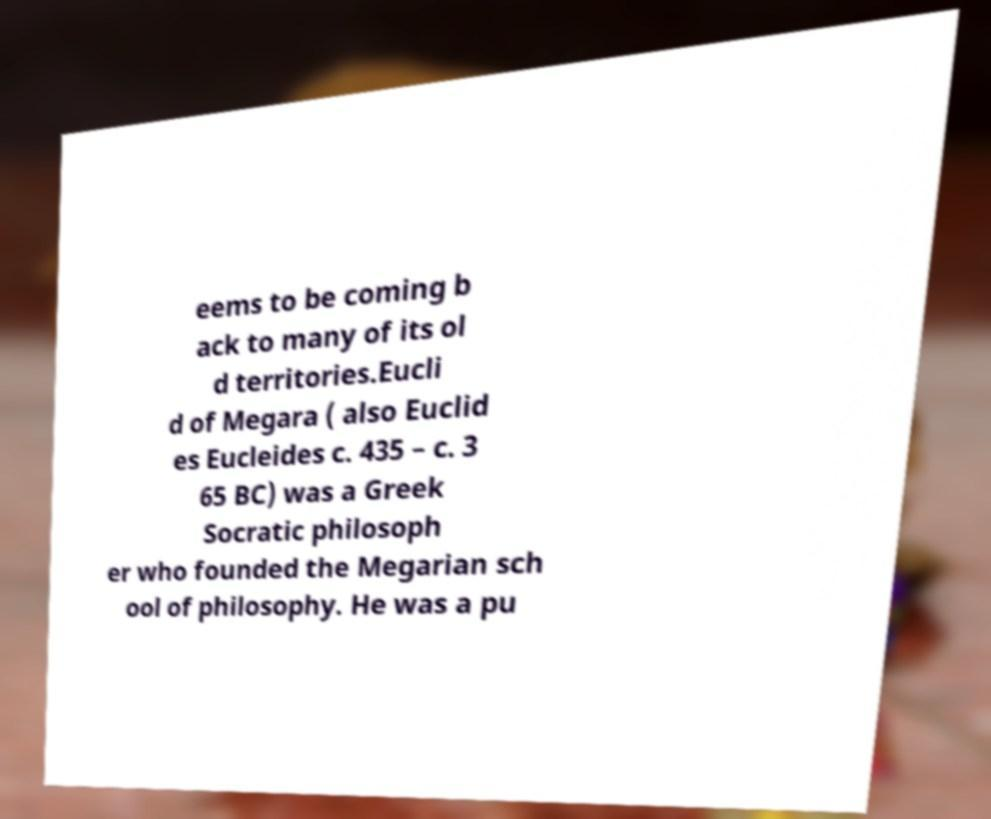I need the written content from this picture converted into text. Can you do that? eems to be coming b ack to many of its ol d territories.Eucli d of Megara ( also Euclid es Eucleides c. 435 – c. 3 65 BC) was a Greek Socratic philosoph er who founded the Megarian sch ool of philosophy. He was a pu 